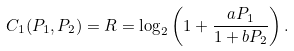Convert formula to latex. <formula><loc_0><loc_0><loc_500><loc_500>C _ { 1 } ( P _ { 1 } , P _ { 2 } ) = R = \log _ { 2 } \left ( 1 + \frac { a P _ { 1 } } { 1 + b P _ { 2 } } \right ) .</formula> 